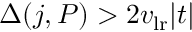<formula> <loc_0><loc_0><loc_500><loc_500>\Delta ( j , P ) > 2 v _ { l r } | t |</formula> 